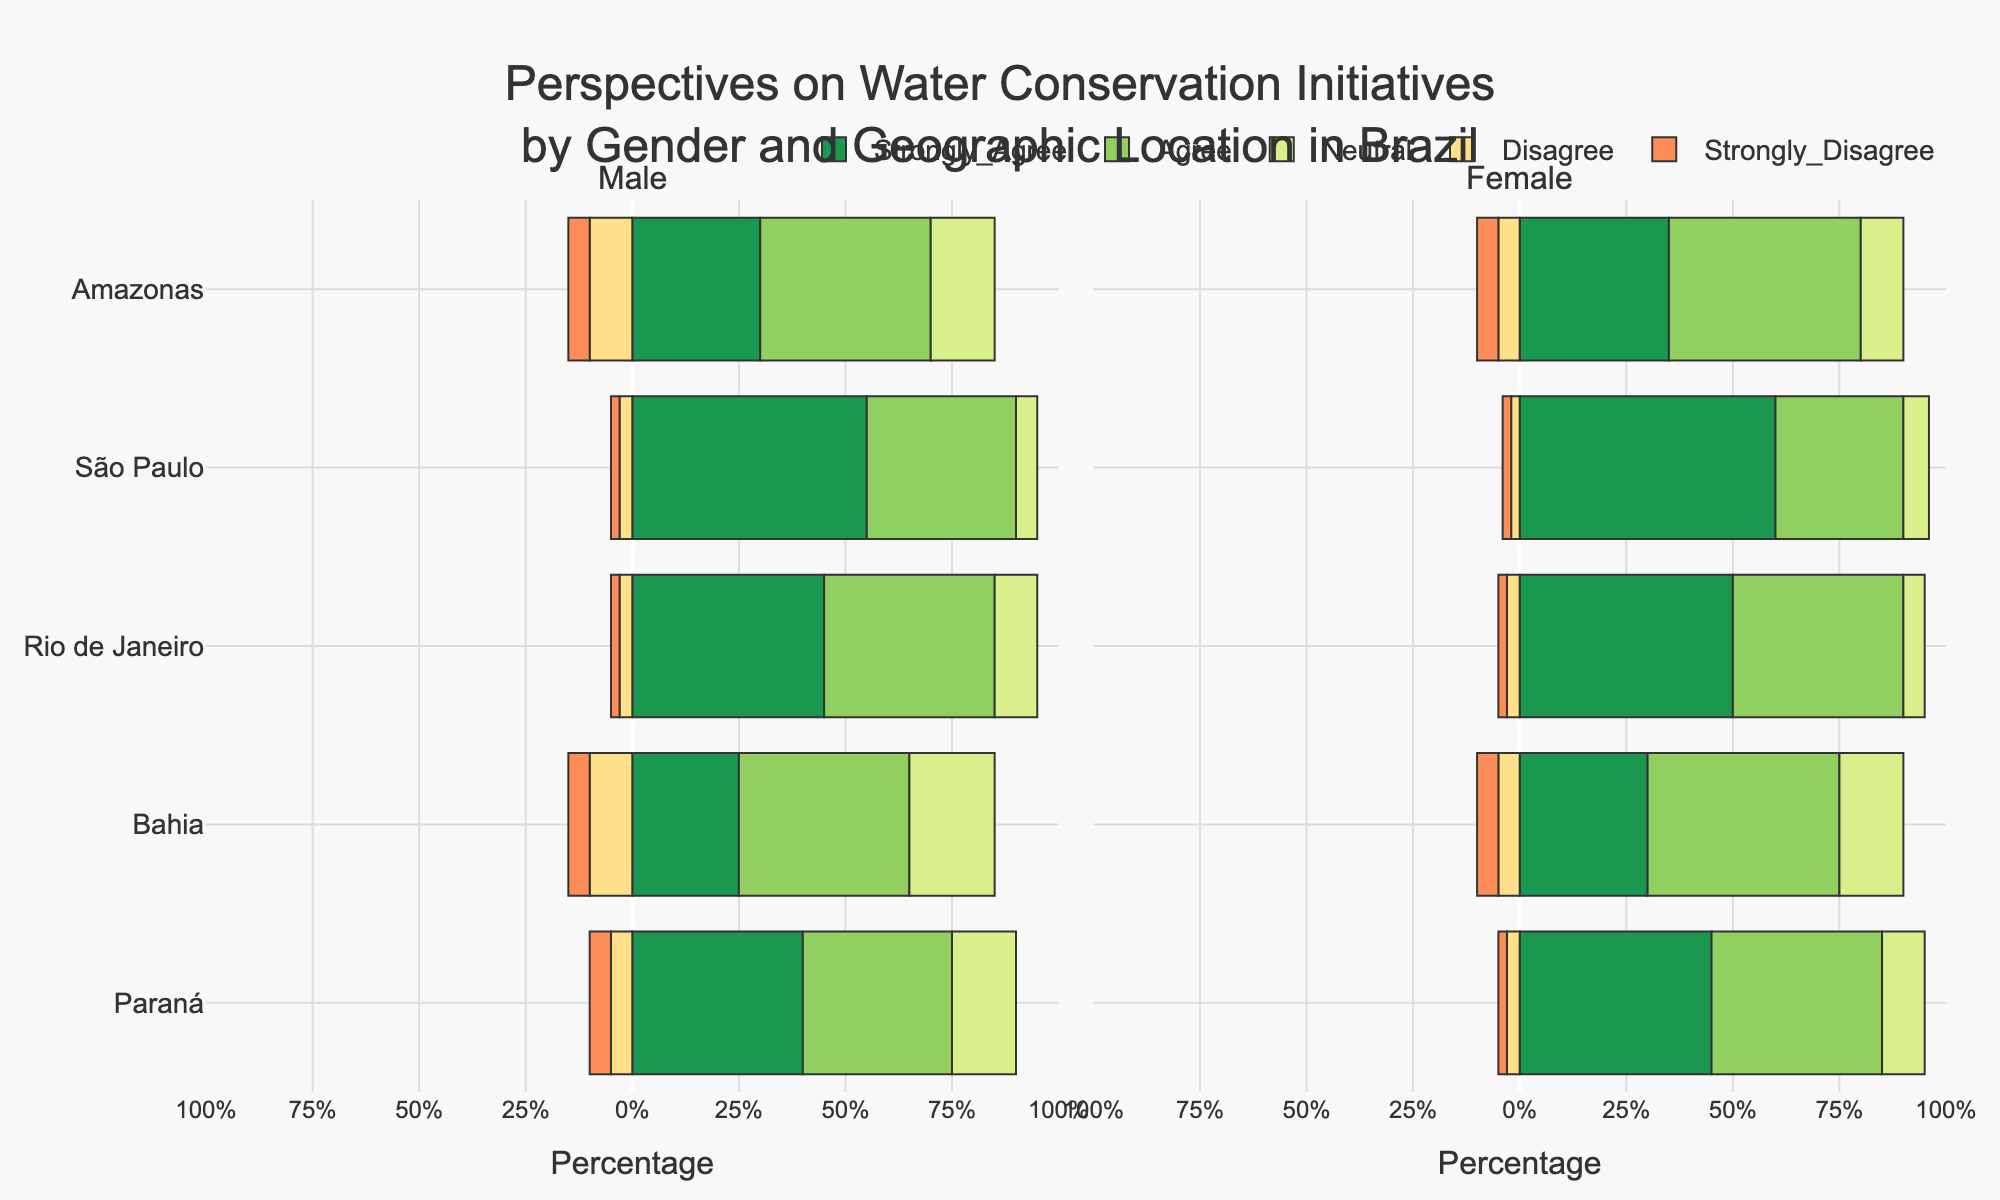What is the percentage of women in São Paulo who agree with water conservation initiatives? Look at the bar representing 'Agree' for females in São Paulo. The height of this bar shows the percentage.
Answer: 30% Which region shows the highest percentage of males who strongly agree with water conservation initiatives? Examine the bars for 'Strongly Agree' among males across all regions. The tallest bar indicates the highest percentage.
Answer: São Paulo How does the percentage of neutrality among females in Bahia compare to those in Paraná? Compare the length of the 'Neutral' bar for females between Bahia and Paraná. Bahia (shorter bar) has a lower percentage than Paraná.
Answer: Paraná's percentage is higher Which gender shows a higher overall positivity (Agree and Strongly Agree) towards water conservation in Rio de Janeiro? Sum the percentages of 'Strongly Agree' and 'Agree' for both males and females in Rio de Janeiro. For males: 45% + 40% = 85%, for females: 50% + 40% = 90%.
Answer: Females Is there any region where both males and females show an equal percentage of strong disagreement? Check the bars for 'Strongly Disagree' for both genders across each region. In Amazonas, both categories have the same height.
Answer: Amazonas What is the total percentage of disagreement (Disagree + Strongly Disagree) for males in Bahia? Add the percentages of 'Disagree' and 'Strongly Disagree' for males in Bahia: 10% + 5% = 15%.
Answer: 15% In Paraná, which gender has a higher percentage of neutrality? Compare the 'Neutral' bars for males and females in Paraná. Males show a higher bar (15%) compared to females (10%).
Answer: Males Between Amazonas and Bahia, which region has a higher percentage of females who strongly agree with the initiatives? Compare the 'Strongly Agree' bars for females between Amazonas and Bahia. The taller bar represents a higher percentage.
Answer: Amazonas Which regions show a higher percentage of positive responses (Agree + Strongly Agree) than neutral and negative responses combined for females? Sum the 'Agree' and 'Strongly Agree' percentages and compare them to the sum of 'Neutral', 'Disagree', and 'Strongly Disagree' percentages for females in each region. São Paulo, Rio de Janeiro, and Paraná fall into this category.
Answer: São Paulo, Rio de Janeiro, Paraná 